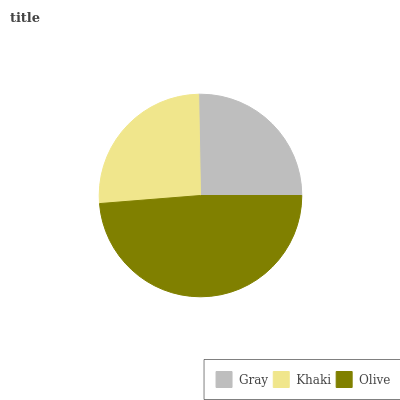Is Gray the minimum?
Answer yes or no. Yes. Is Olive the maximum?
Answer yes or no. Yes. Is Khaki the minimum?
Answer yes or no. No. Is Khaki the maximum?
Answer yes or no. No. Is Khaki greater than Gray?
Answer yes or no. Yes. Is Gray less than Khaki?
Answer yes or no. Yes. Is Gray greater than Khaki?
Answer yes or no. No. Is Khaki less than Gray?
Answer yes or no. No. Is Khaki the high median?
Answer yes or no. Yes. Is Khaki the low median?
Answer yes or no. Yes. Is Gray the high median?
Answer yes or no. No. Is Olive the low median?
Answer yes or no. No. 